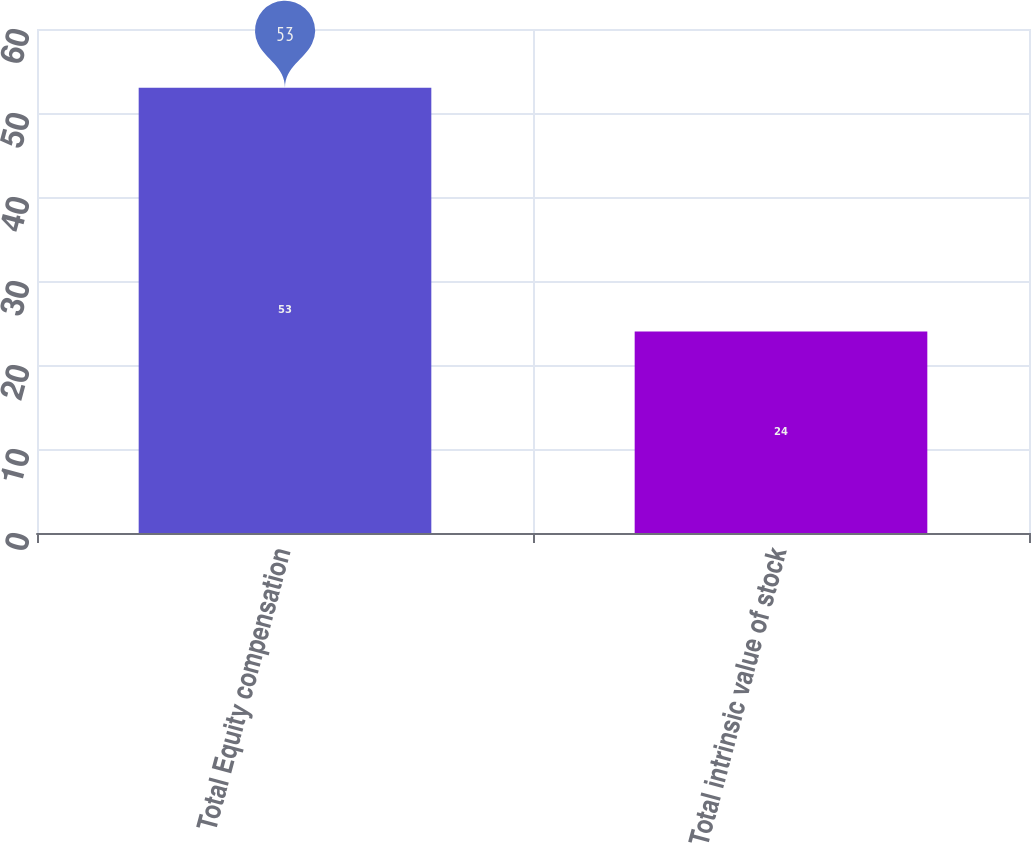Convert chart. <chart><loc_0><loc_0><loc_500><loc_500><bar_chart><fcel>Total Equity compensation<fcel>Total intrinsic value of stock<nl><fcel>53<fcel>24<nl></chart> 